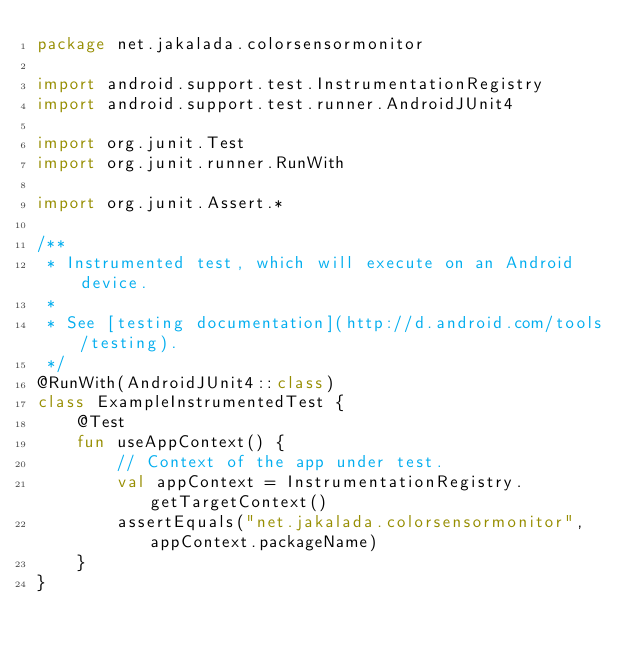Convert code to text. <code><loc_0><loc_0><loc_500><loc_500><_Kotlin_>package net.jakalada.colorsensormonitor

import android.support.test.InstrumentationRegistry
import android.support.test.runner.AndroidJUnit4

import org.junit.Test
import org.junit.runner.RunWith

import org.junit.Assert.*

/**
 * Instrumented test, which will execute on an Android device.
 *
 * See [testing documentation](http://d.android.com/tools/testing).
 */
@RunWith(AndroidJUnit4::class)
class ExampleInstrumentedTest {
    @Test
    fun useAppContext() {
        // Context of the app under test.
        val appContext = InstrumentationRegistry.getTargetContext()
        assertEquals("net.jakalada.colorsensormonitor", appContext.packageName)
    }
}
</code> 